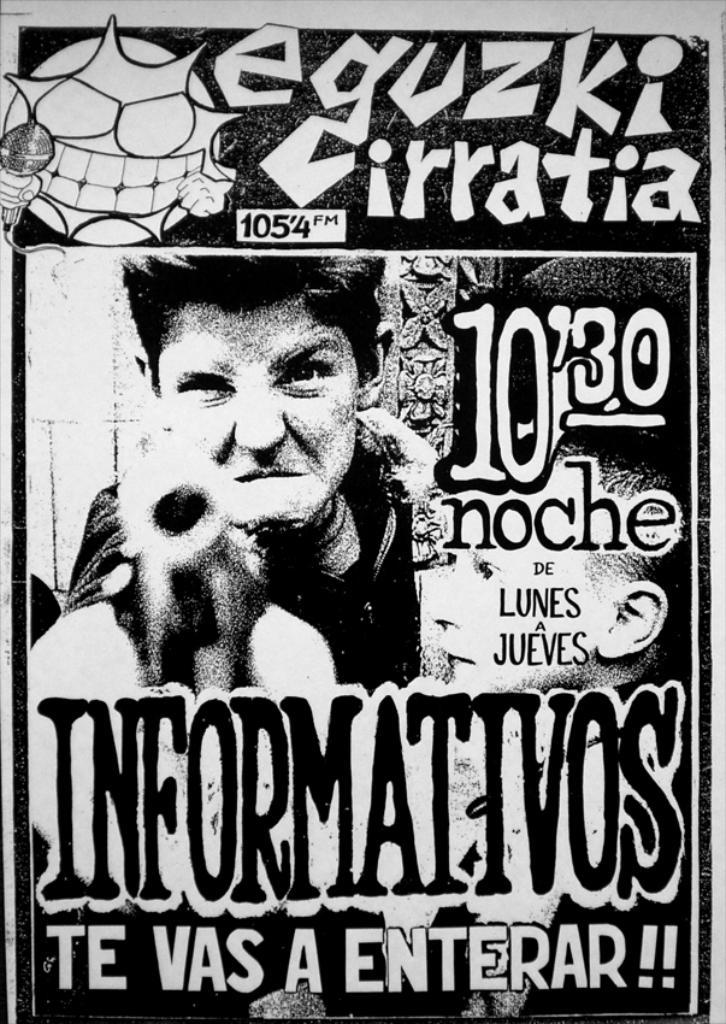Provide a one-sentence caption for the provided image. A poster for eguzki cirratia is printed in black and white. 